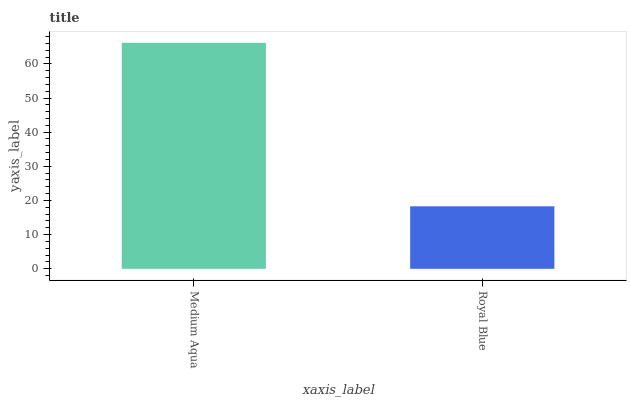Is Royal Blue the minimum?
Answer yes or no. Yes. Is Medium Aqua the maximum?
Answer yes or no. Yes. Is Royal Blue the maximum?
Answer yes or no. No. Is Medium Aqua greater than Royal Blue?
Answer yes or no. Yes. Is Royal Blue less than Medium Aqua?
Answer yes or no. Yes. Is Royal Blue greater than Medium Aqua?
Answer yes or no. No. Is Medium Aqua less than Royal Blue?
Answer yes or no. No. Is Medium Aqua the high median?
Answer yes or no. Yes. Is Royal Blue the low median?
Answer yes or no. Yes. Is Royal Blue the high median?
Answer yes or no. No. Is Medium Aqua the low median?
Answer yes or no. No. 